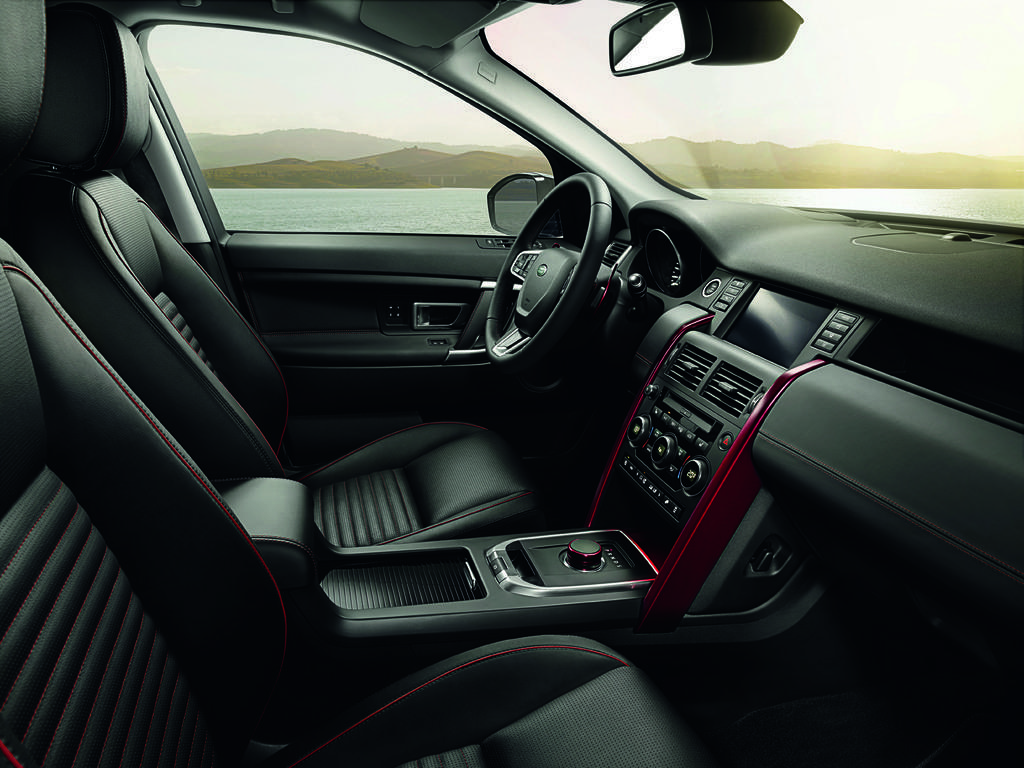Can you describe this image briefly? In this image there is an interior view of the car and steering, outside the car there are few mountains, water and the sky. 